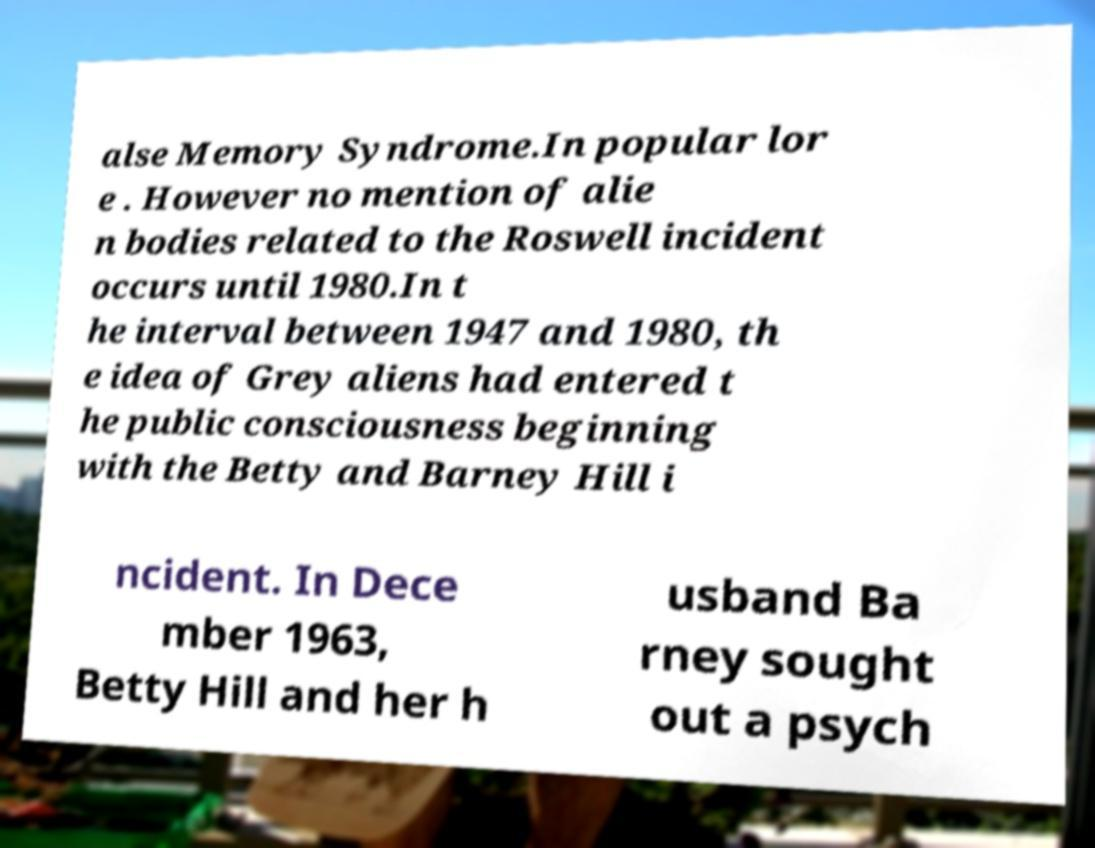There's text embedded in this image that I need extracted. Can you transcribe it verbatim? alse Memory Syndrome.In popular lor e . However no mention of alie n bodies related to the Roswell incident occurs until 1980.In t he interval between 1947 and 1980, th e idea of Grey aliens had entered t he public consciousness beginning with the Betty and Barney Hill i ncident. In Dece mber 1963, Betty Hill and her h usband Ba rney sought out a psych 